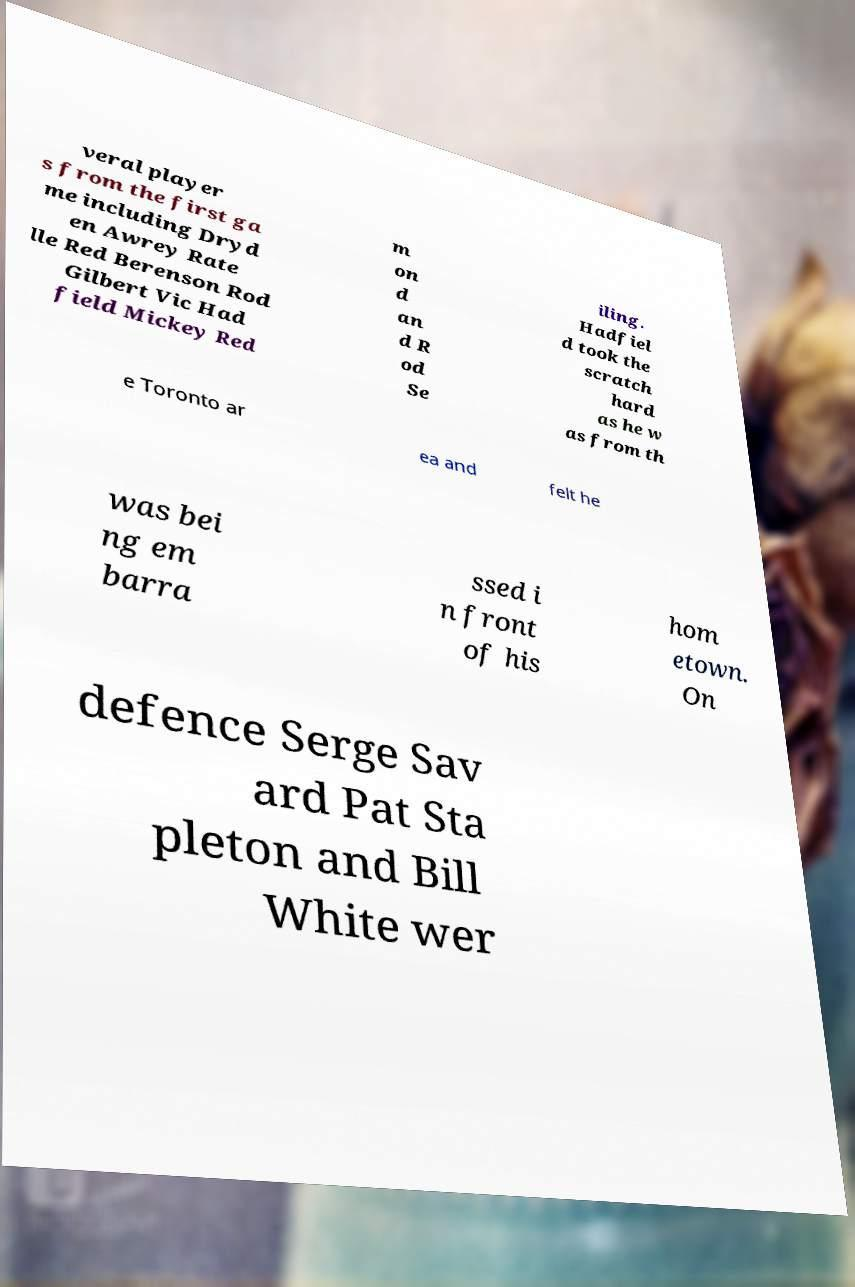There's text embedded in this image that I need extracted. Can you transcribe it verbatim? veral player s from the first ga me including Dryd en Awrey Rate lle Red Berenson Rod Gilbert Vic Had field Mickey Red m on d an d R od Se iling. Hadfiel d took the scratch hard as he w as from th e Toronto ar ea and felt he was bei ng em barra ssed i n front of his hom etown. On defence Serge Sav ard Pat Sta pleton and Bill White wer 